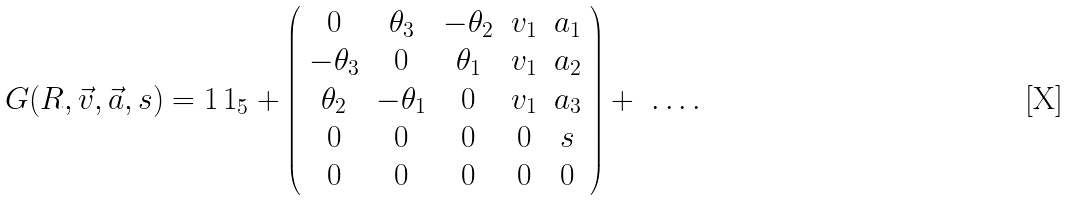Convert formula to latex. <formula><loc_0><loc_0><loc_500><loc_500>G ( R , { \vec { v } } , { \vec { a } } , s ) = 1 \, 1 _ { 5 } + \left ( { \begin{array} { c c c c c } { 0 } & { \theta _ { 3 } } & { - \theta _ { 2 } } & { v _ { 1 } } & { a _ { 1 } } \\ { - \theta _ { 3 } } & { 0 } & { \theta _ { 1 } } & { v _ { 1 } } & { a _ { 2 } } \\ { \theta _ { 2 } } & { - \theta _ { 1 } } & { 0 } & { v _ { 1 } } & { a _ { 3 } } \\ { 0 } & { 0 } & { 0 } & { 0 } & { s } \\ { 0 } & { 0 } & { 0 } & { 0 } & { 0 } \end{array} } \right ) + \ \dots .</formula> 